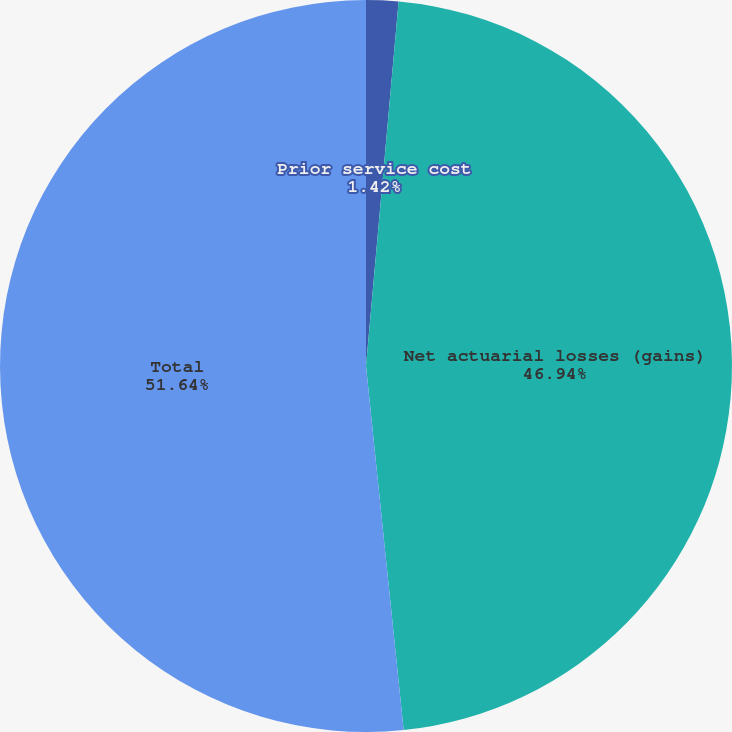Convert chart to OTSL. <chart><loc_0><loc_0><loc_500><loc_500><pie_chart><fcel>Prior service cost<fcel>Net actuarial losses (gains)<fcel>Total<nl><fcel>1.42%<fcel>46.94%<fcel>51.64%<nl></chart> 